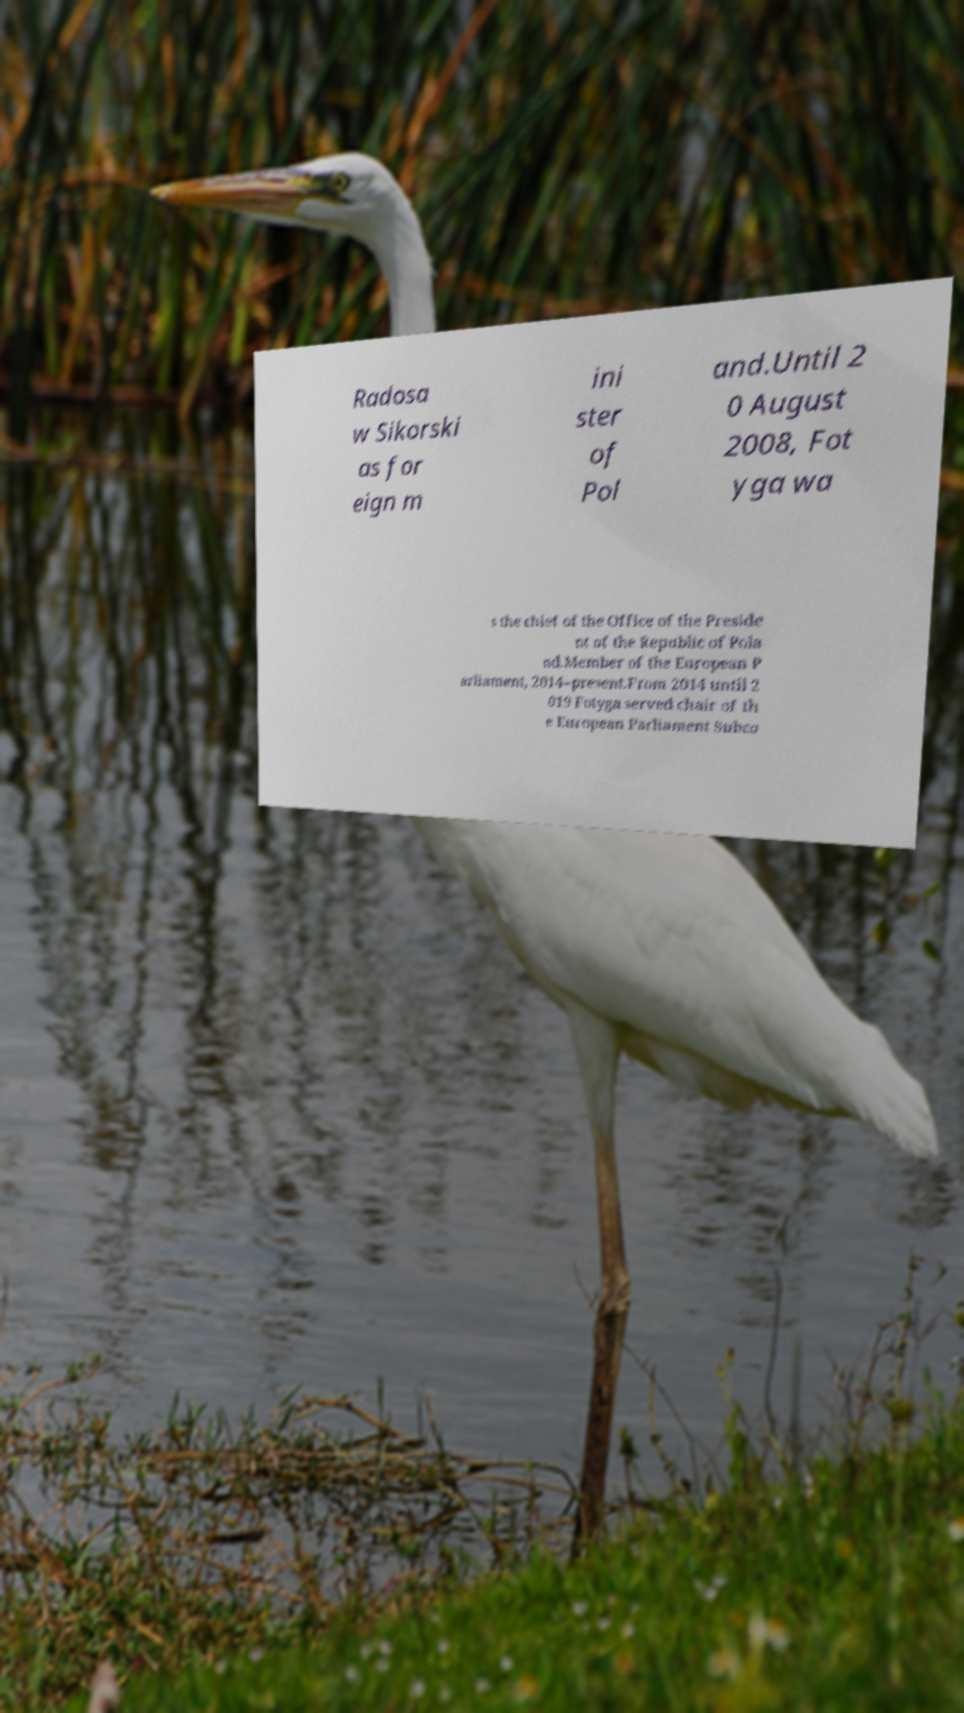Please identify and transcribe the text found in this image. Radosa w Sikorski as for eign m ini ster of Pol and.Until 2 0 August 2008, Fot yga wa s the chief of the Office of the Preside nt of the Republic of Pola nd.Member of the European P arliament, 2014–present.From 2014 until 2 019 Fotyga served chair of th e European Parliament Subco 